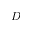<formula> <loc_0><loc_0><loc_500><loc_500>D</formula> 